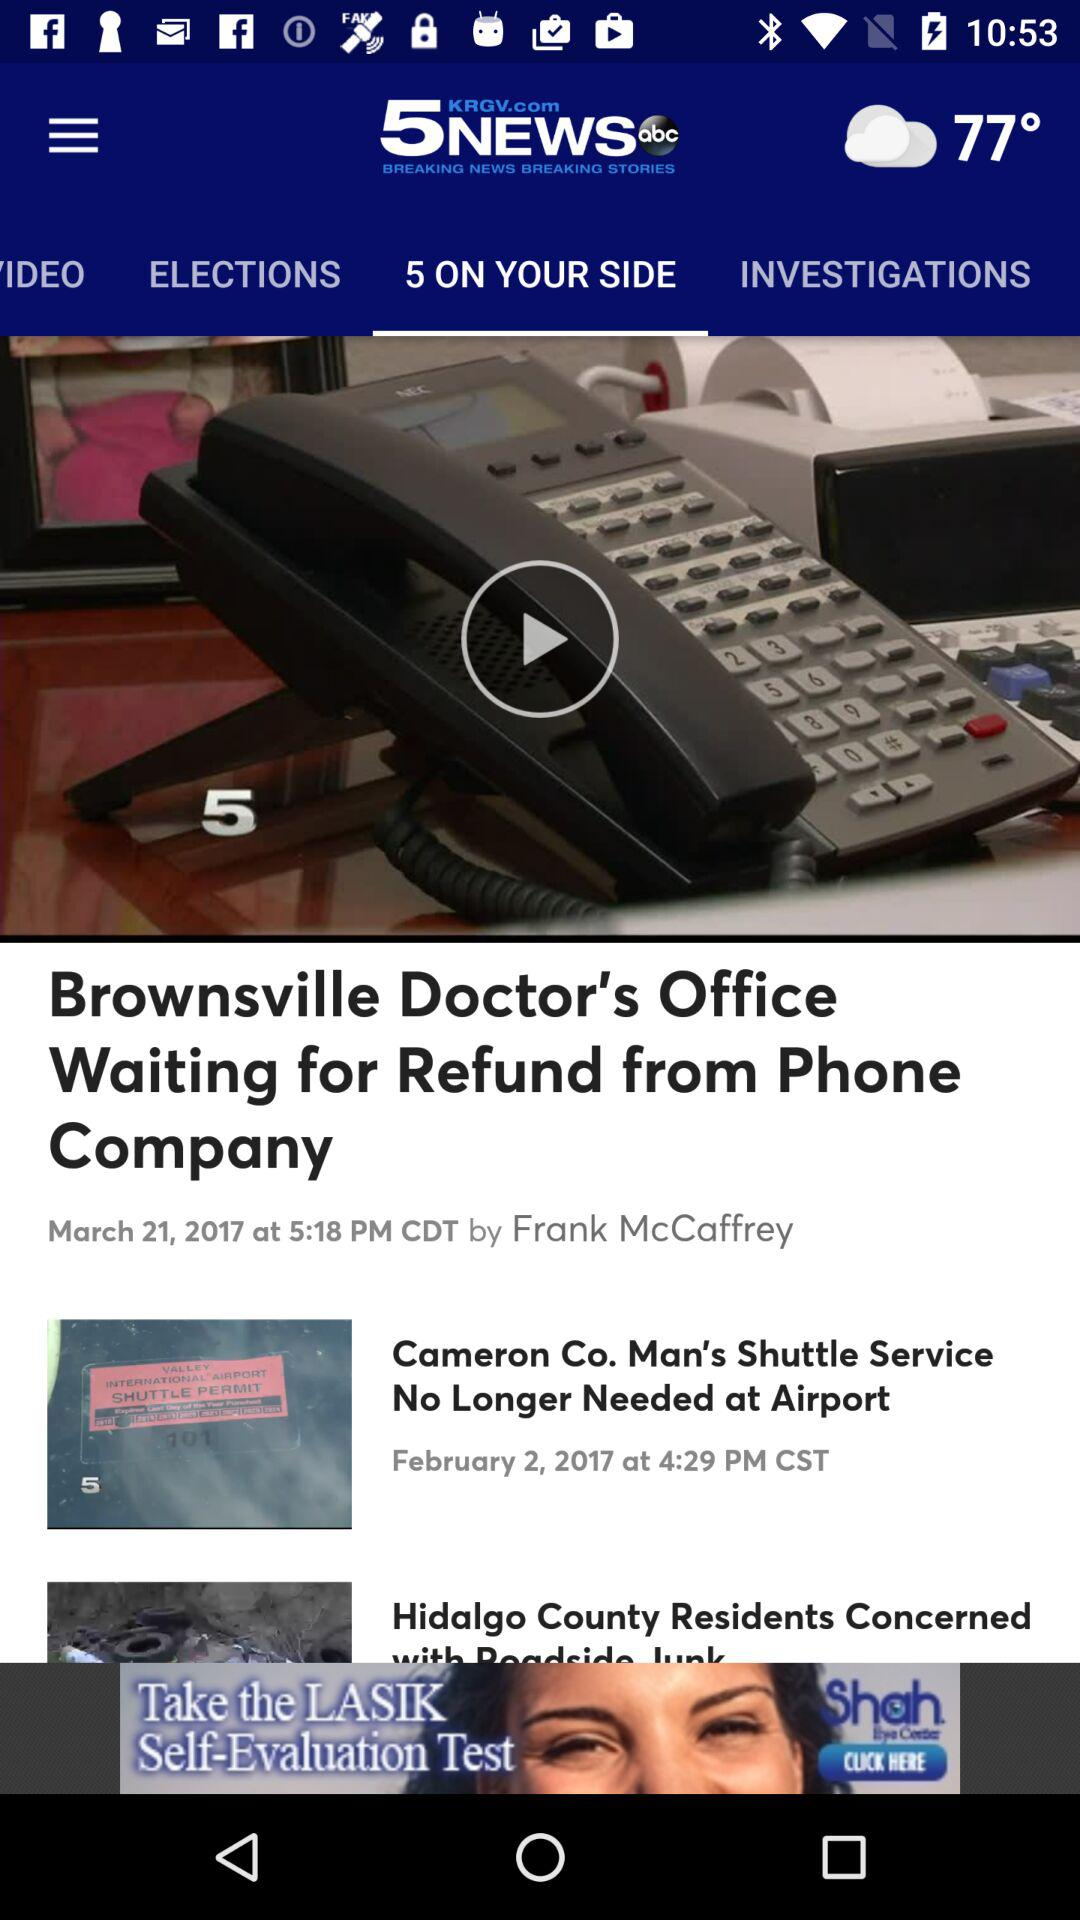What is the name of the application? The name of the application is "KRGV 5 News". 